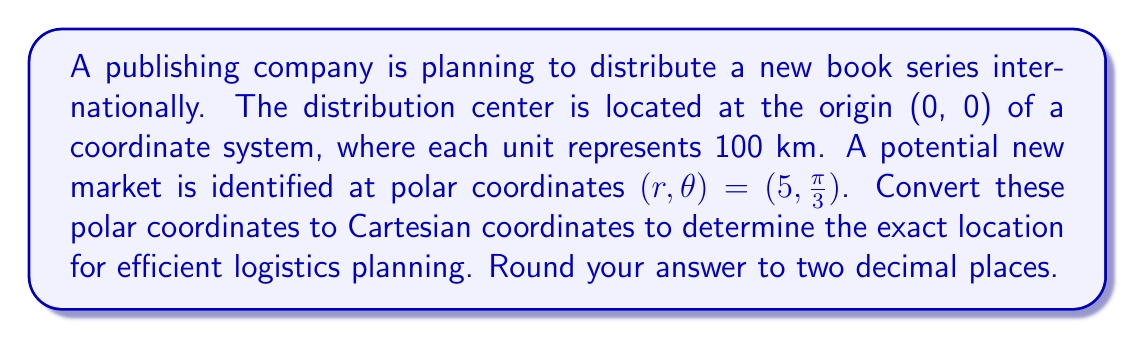Provide a solution to this math problem. To convert polar coordinates $(r, \theta)$ to Cartesian coordinates $(x, y)$, we use the following formulas:

$$x = r \cos(\theta)$$
$$y = r \sin(\theta)$$

Given:
$r = 5$
$\theta = \frac{\pi}{3}$

Step 1: Calculate x-coordinate
$$x = r \cos(\theta) = 5 \cos(\frac{\pi}{3})$$

We know that $\cos(\frac{\pi}{3}) = \frac{1}{2}$, so:

$$x = 5 \cdot \frac{1}{2} = 2.5$$

Step 2: Calculate y-coordinate
$$y = r \sin(\theta) = 5 \sin(\frac{\pi}{3})$$

We know that $\sin(\frac{\pi}{3}) = \frac{\sqrt{3}}{2}$, so:

$$y = 5 \cdot \frac{\sqrt{3}}{2} = \frac{5\sqrt{3}}{2} \approx 4.33$$

Step 3: Round both coordinates to two decimal places

x ≈ 2.50
y ≈ 4.33

Therefore, the Cartesian coordinates are approximately (2.50, 4.33).

[asy]
import graph;
size(200);
real r = 5;
real theta = pi/3;
real x = r*cos(theta);
real y = r*sin(theta);
draw((-1,0)--(6,0), arrow=Arrow(TeXHead));
draw((0,-1)--(0,5), arrow=Arrow(TeXHead));
draw((0,0)--(x,y), arrow=Arrow(TeXHead), red);
dot((x,y), red);
label("(2.50, 4.33)", (x,y), NE);
label("x", (6,0), E);
label("y", (0,5), N);
[/asy]
Answer: (2.50, 4.33) 